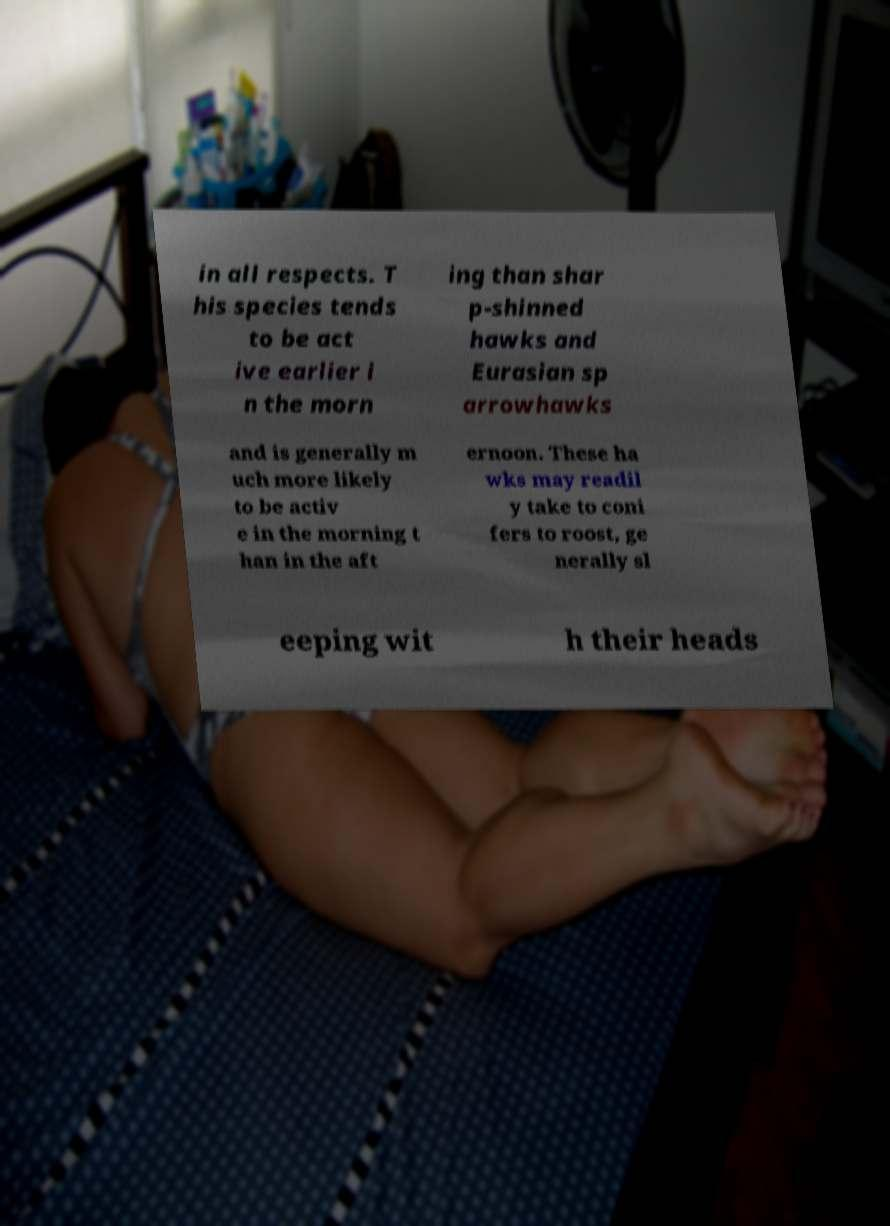Could you assist in decoding the text presented in this image and type it out clearly? in all respects. T his species tends to be act ive earlier i n the morn ing than shar p-shinned hawks and Eurasian sp arrowhawks and is generally m uch more likely to be activ e in the morning t han in the aft ernoon. These ha wks may readil y take to coni fers to roost, ge nerally sl eeping wit h their heads 